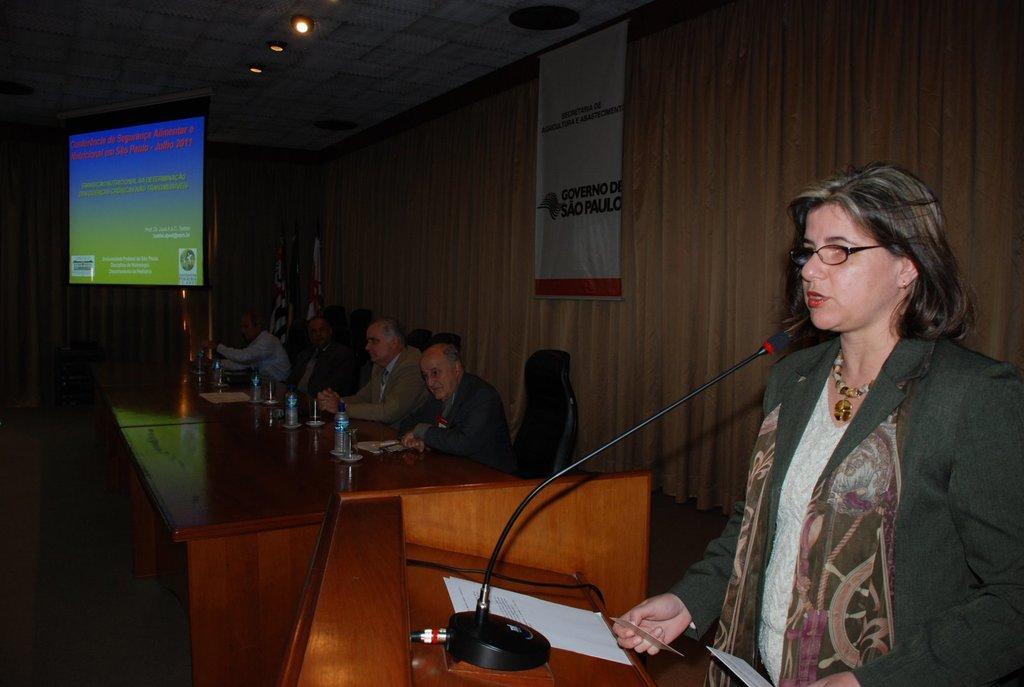In one or two sentences, can you explain what this image depicts? In this image I can see group of people sitting. In front the person is standing and I can also see the podium and the microphone. In the background I can see the projection screen and I can also see few lights. 